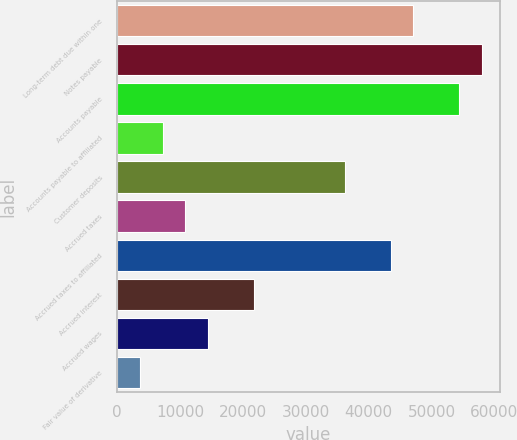<chart> <loc_0><loc_0><loc_500><loc_500><bar_chart><fcel>Long-term debt due within one<fcel>Notes payable<fcel>Accounts payable<fcel>Accounts payable to affiliated<fcel>Customer deposits<fcel>Accrued taxes<fcel>Accrued taxes to affiliated<fcel>Accrued interest<fcel>Accrued wages<fcel>Fair value of derivative<nl><fcel>47135.1<fcel>58012.2<fcel>54386.5<fcel>7252.4<fcel>36258<fcel>10878.1<fcel>43509.4<fcel>21755.2<fcel>14503.8<fcel>3626.7<nl></chart> 